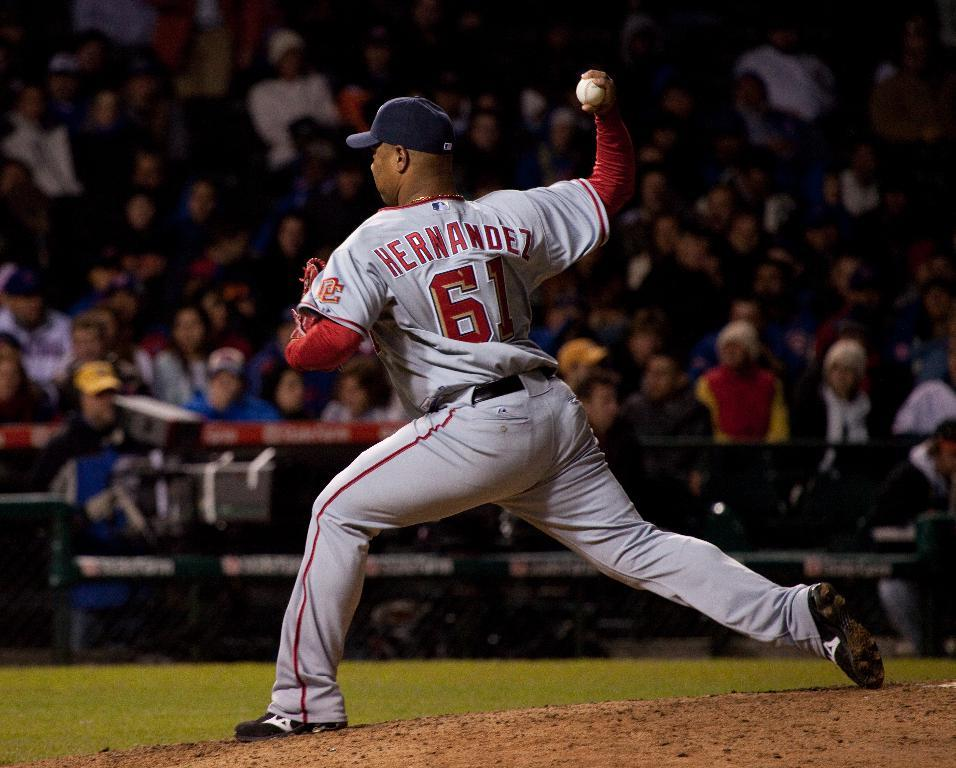<image>
Summarize the visual content of the image. The pitcher in the picture is named Hernandez 